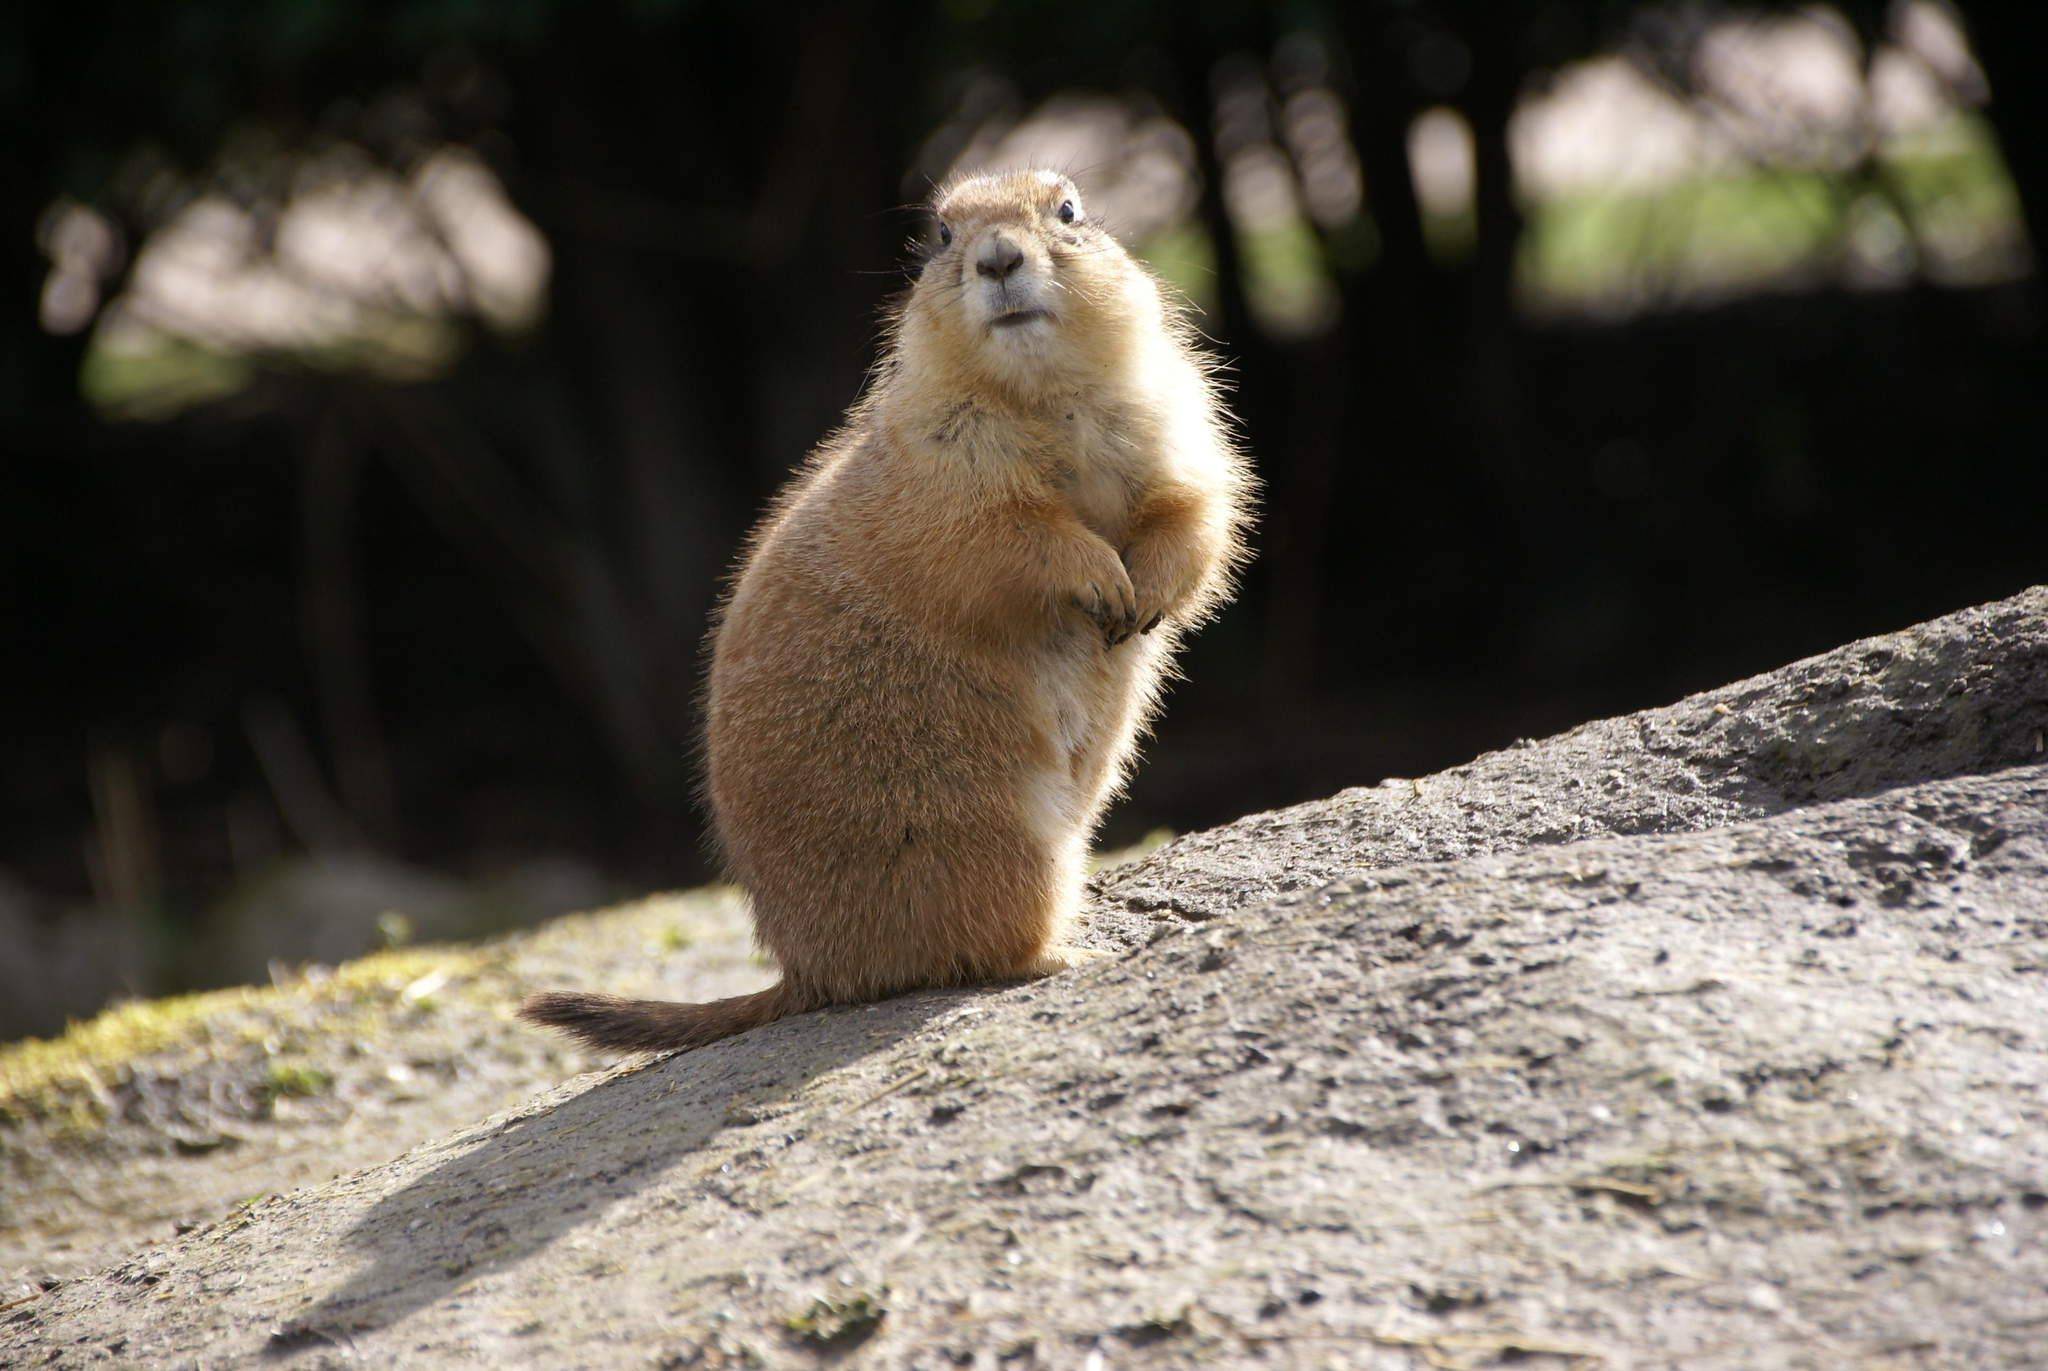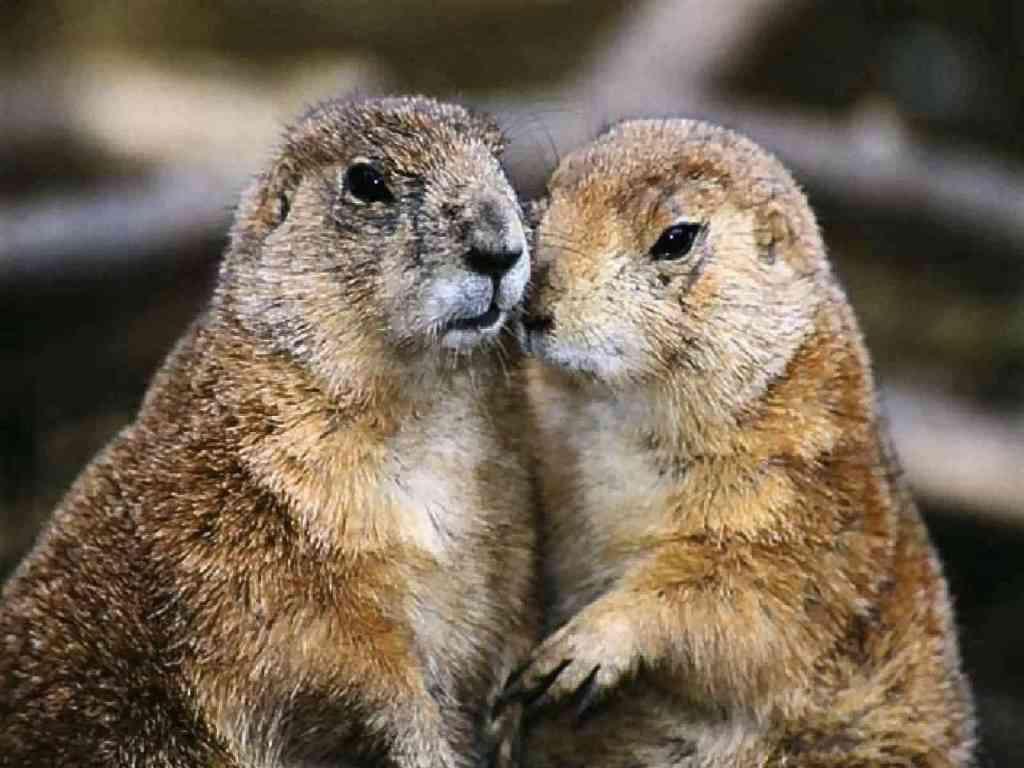The first image is the image on the left, the second image is the image on the right. Examine the images to the left and right. Is the description "There are two brown furry little animals outside." accurate? Answer yes or no. No. The first image is the image on the left, the second image is the image on the right. Assess this claim about the two images: "Two groundhogs are standing very close together.". Correct or not? Answer yes or no. Yes. 